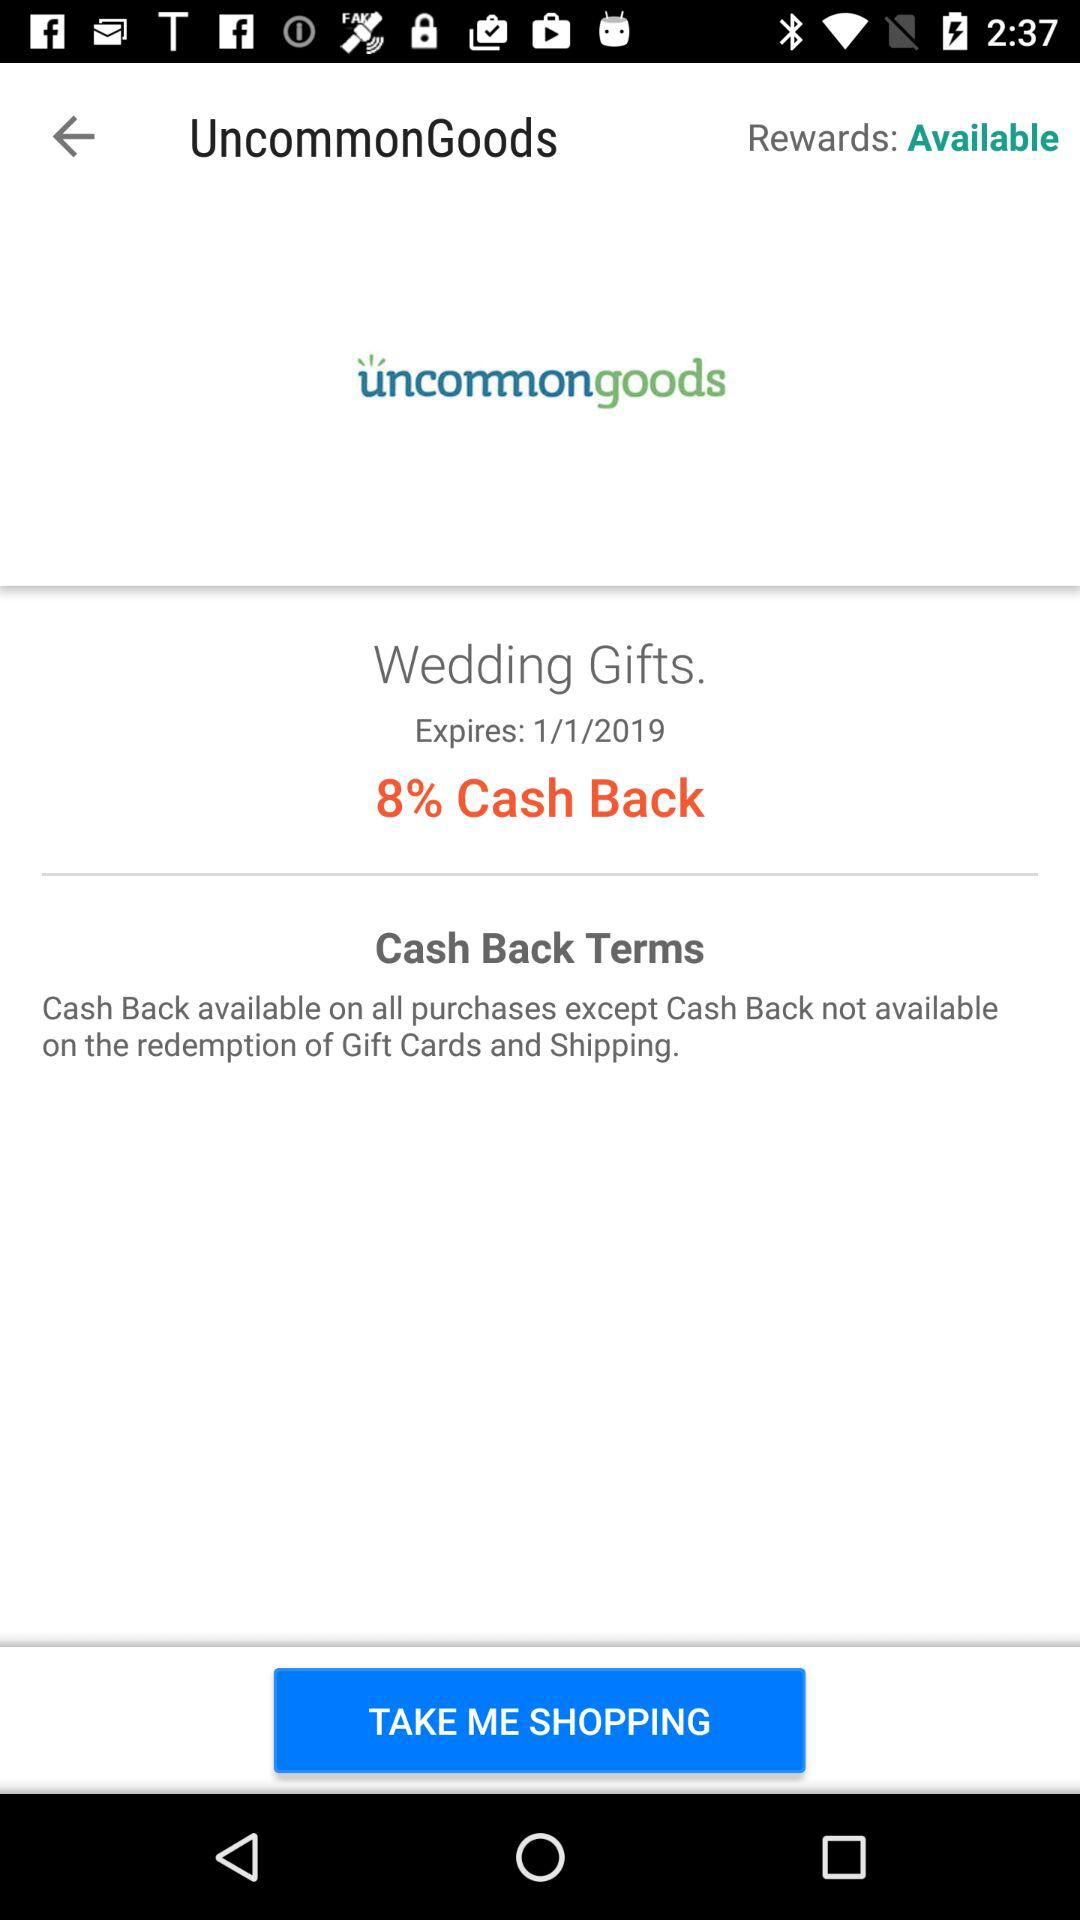What is the name of the application? The name of the application is "uncommongoods". 